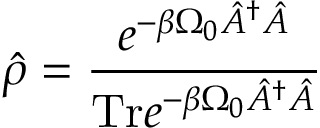<formula> <loc_0><loc_0><loc_500><loc_500>\hat { \rho } = \frac { e ^ { - \beta \Omega _ { 0 } \hat { A } ^ { \dagger } \hat { A } } } { T r e ^ { - \beta \Omega _ { 0 } \hat { A } ^ { \dagger } \hat { A } } }</formula> 